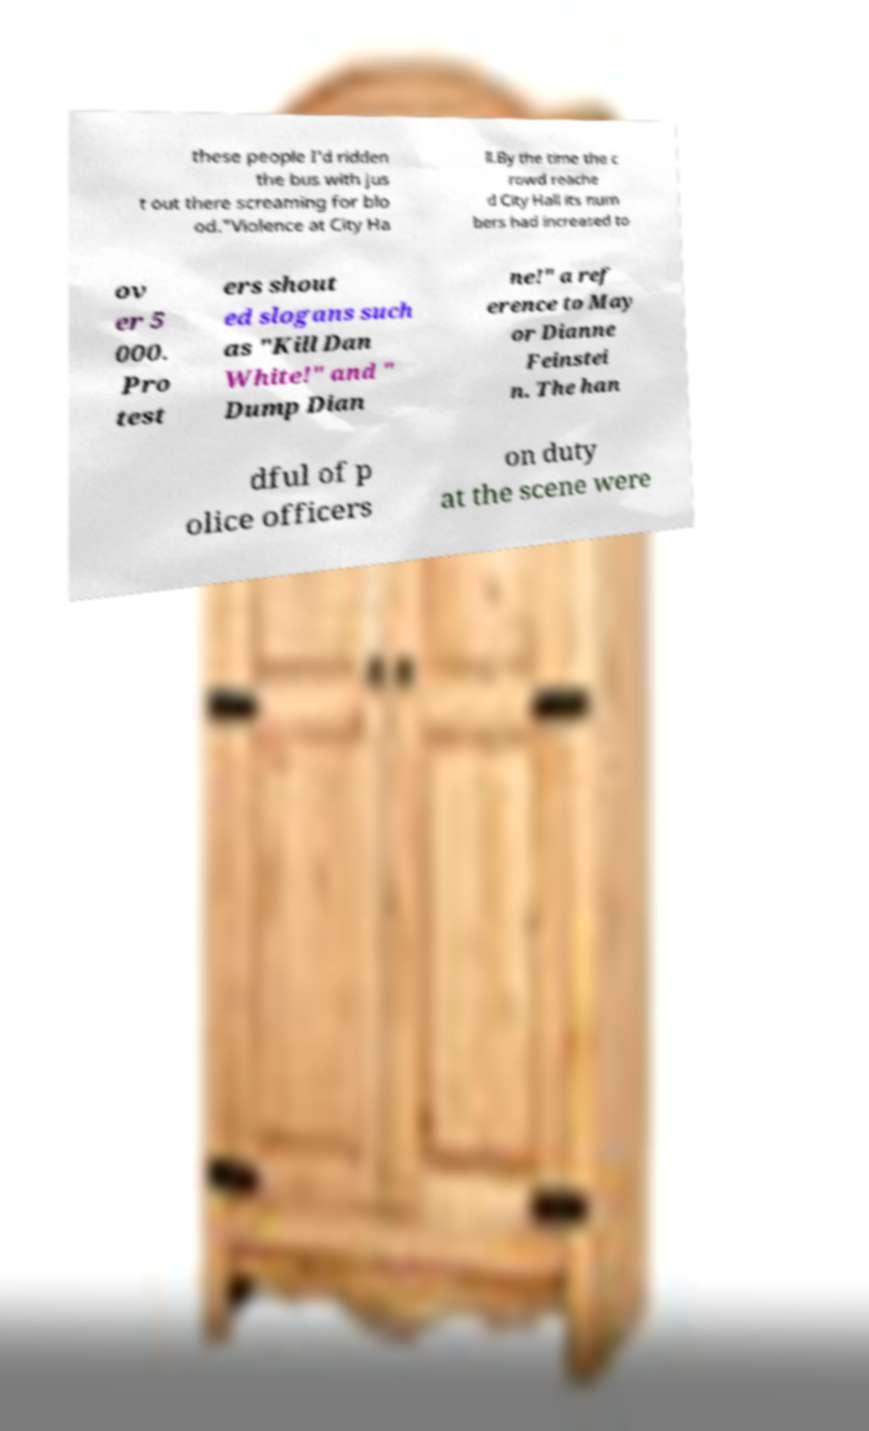Please identify and transcribe the text found in this image. these people I'd ridden the bus with jus t out there screaming for blo od."Violence at City Ha ll.By the time the c rowd reache d City Hall its num bers had increased to ov er 5 000. Pro test ers shout ed slogans such as "Kill Dan White!" and " Dump Dian ne!" a ref erence to May or Dianne Feinstei n. The han dful of p olice officers on duty at the scene were 